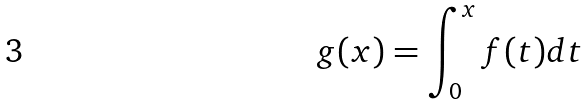Convert formula to latex. <formula><loc_0><loc_0><loc_500><loc_500>g ( x ) = \int _ { 0 } ^ { x } f ( t ) d t</formula> 